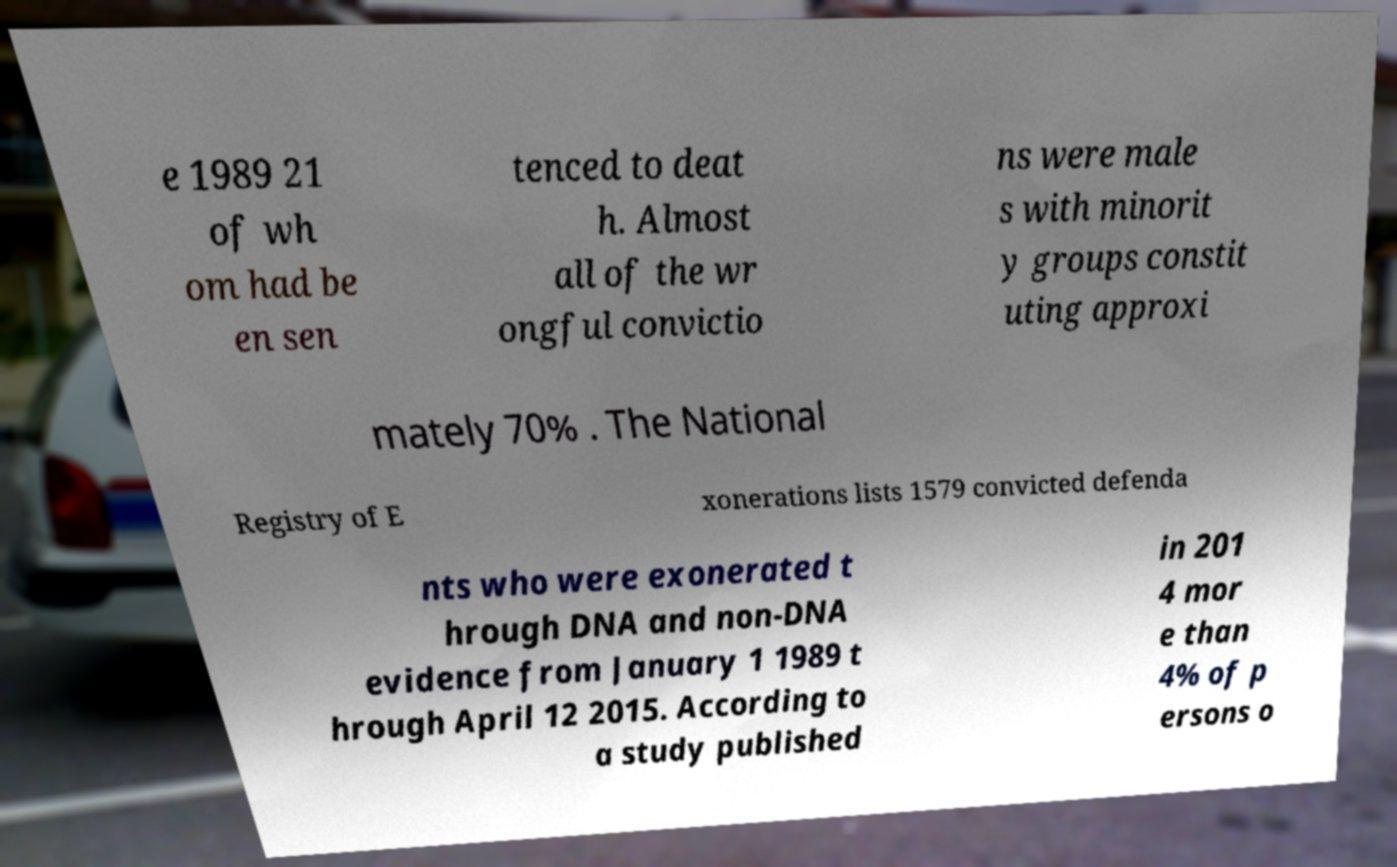Could you extract and type out the text from this image? e 1989 21 of wh om had be en sen tenced to deat h. Almost all of the wr ongful convictio ns were male s with minorit y groups constit uting approxi mately 70% . The National Registry of E xonerations lists 1579 convicted defenda nts who were exonerated t hrough DNA and non-DNA evidence from January 1 1989 t hrough April 12 2015. According to a study published in 201 4 mor e than 4% of p ersons o 